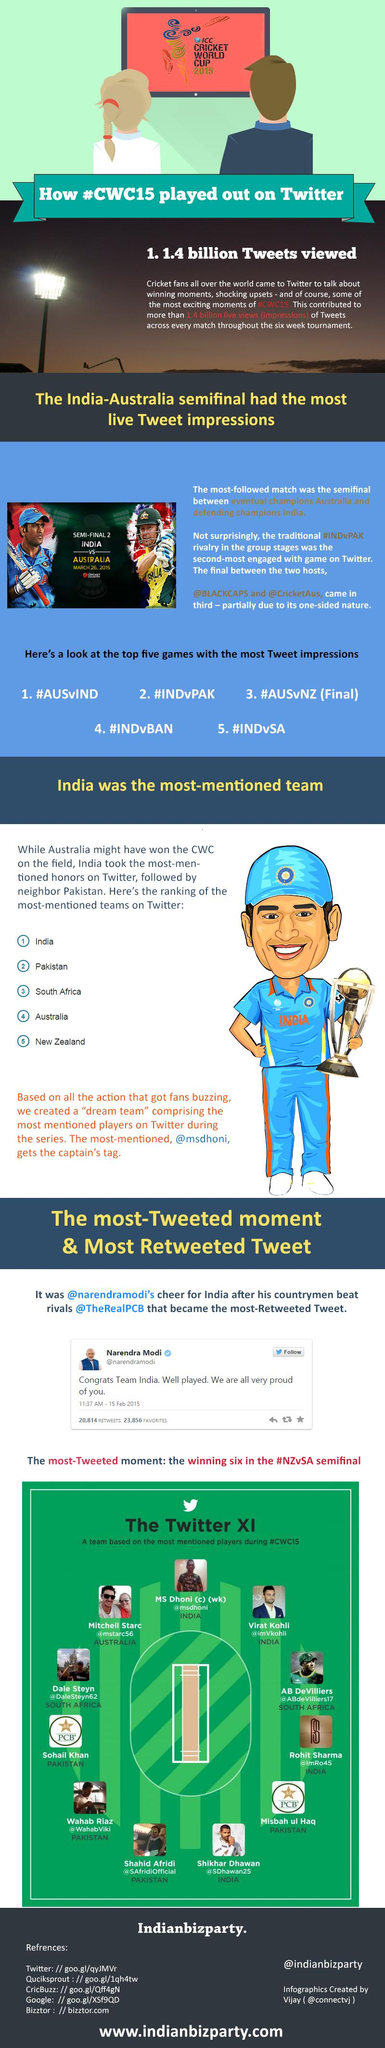Point out several critical features in this image. Virat Kohli, a prominent international cricketer, is a citizen of India. 